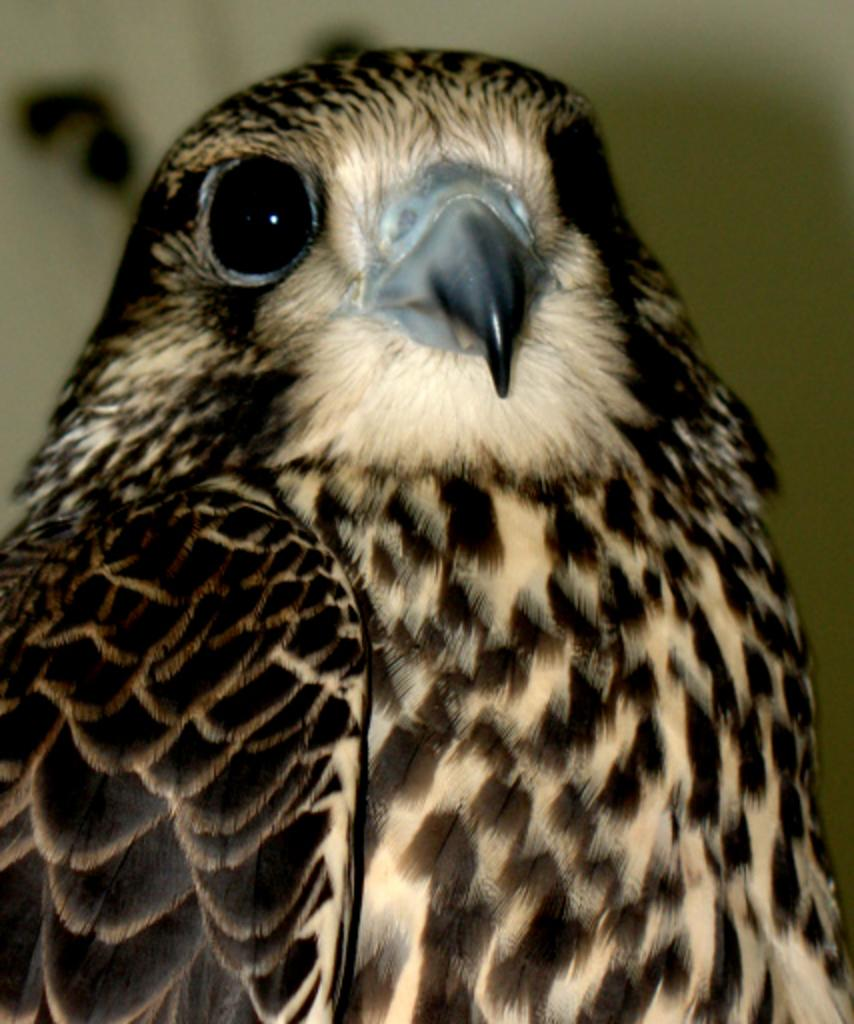What type of animal is present in the image? There is a bird in the image. Can you describe the background of the image? The background of the image is blurred. Where is the faucet located in the image? There is no faucet present in the image. What type of cup is the bird holding in the image? There is no cup or bird holding a cup in the image. 